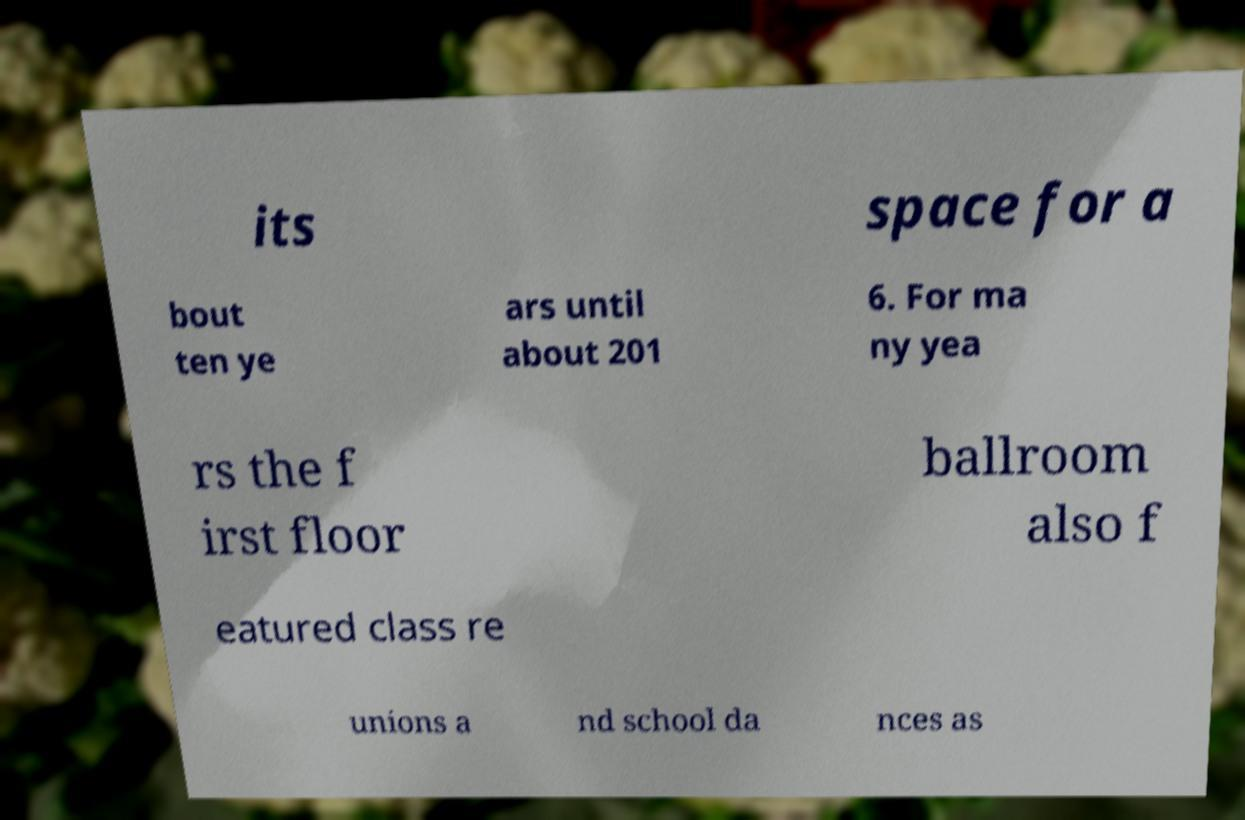Could you assist in decoding the text presented in this image and type it out clearly? its space for a bout ten ye ars until about 201 6. For ma ny yea rs the f irst floor ballroom also f eatured class re unions a nd school da nces as 